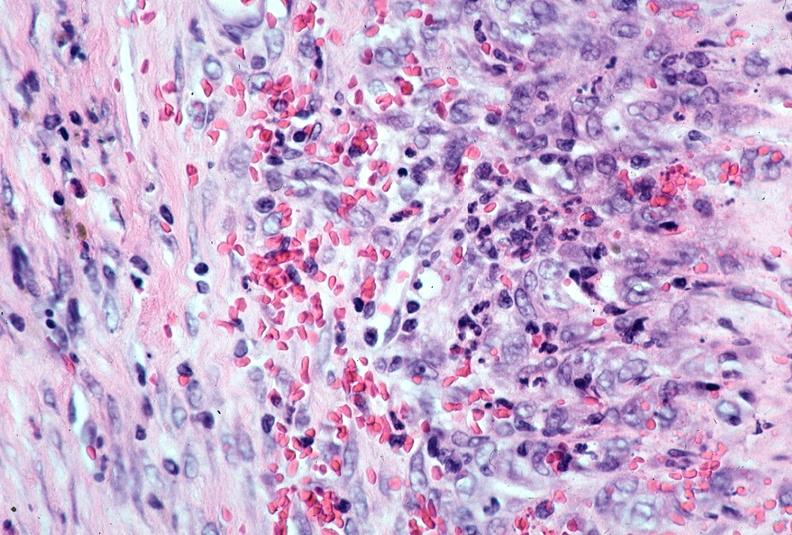does situs inversus show vasculitis, polyarteritis nodosa?
Answer the question using a single word or phrase. No 